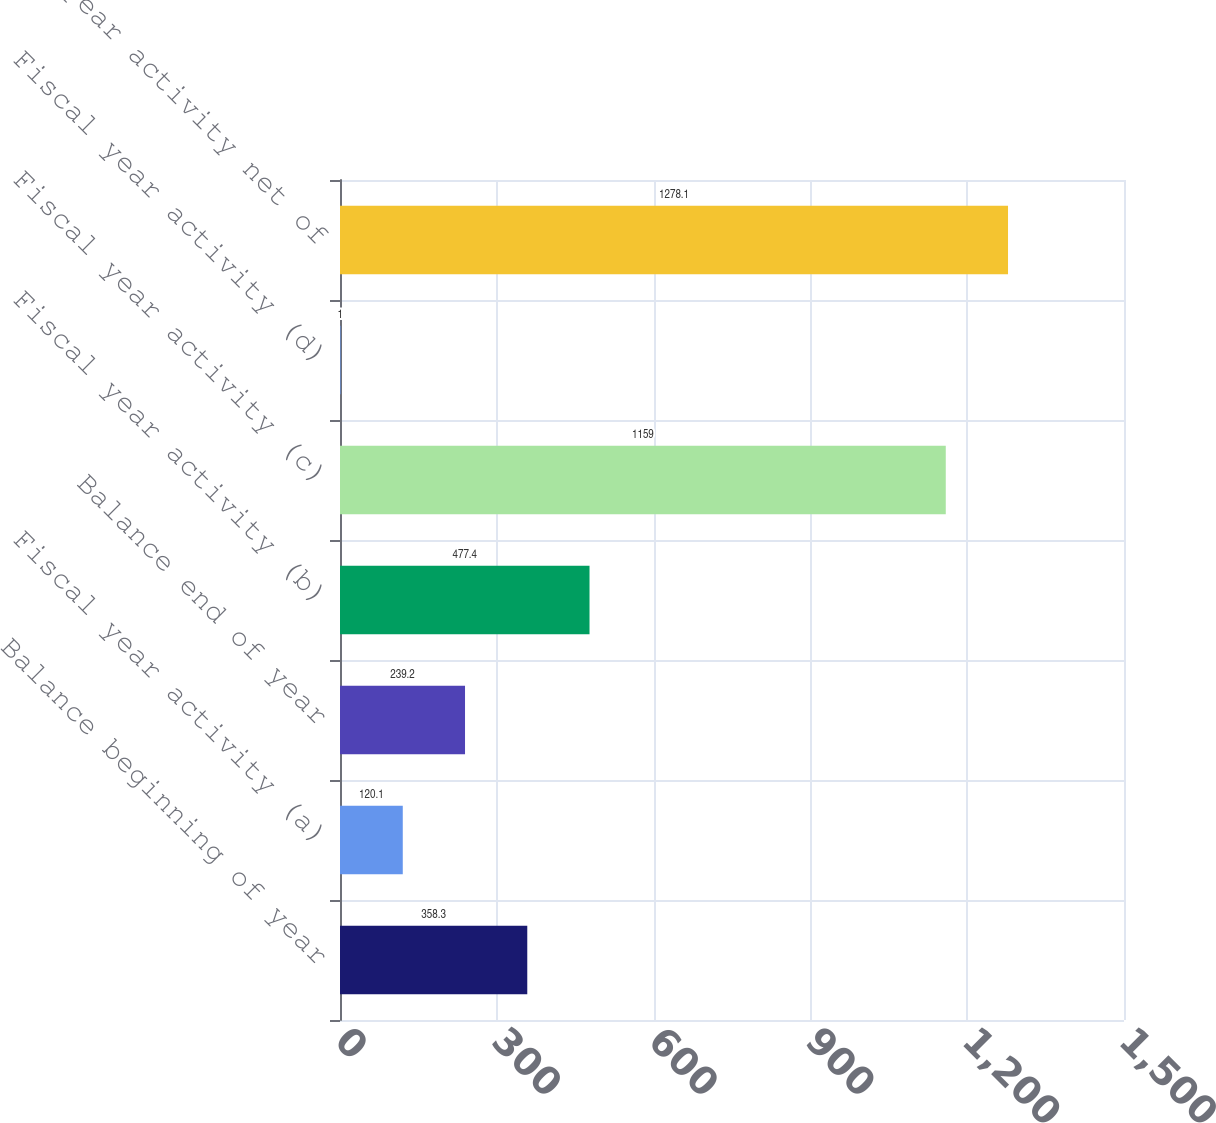Convert chart to OTSL. <chart><loc_0><loc_0><loc_500><loc_500><bar_chart><fcel>Balance beginning of year<fcel>Fiscal year activity (a)<fcel>Balance end of year<fcel>Fiscal year activity (b)<fcel>Fiscal year activity (c)<fcel>Fiscal year activity (d)<fcel>Fiscal year activity net of<nl><fcel>358.3<fcel>120.1<fcel>239.2<fcel>477.4<fcel>1159<fcel>1<fcel>1278.1<nl></chart> 